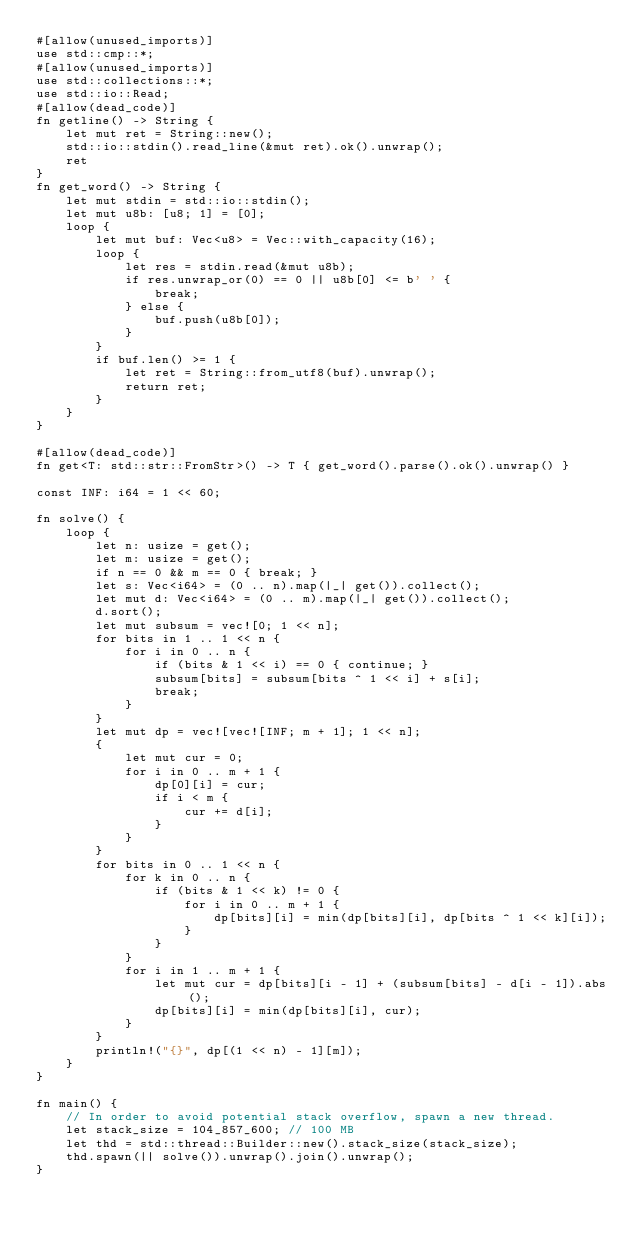Convert code to text. <code><loc_0><loc_0><loc_500><loc_500><_Rust_>#[allow(unused_imports)]
use std::cmp::*;
#[allow(unused_imports)]
use std::collections::*;
use std::io::Read;
#[allow(dead_code)]
fn getline() -> String {
    let mut ret = String::new();
    std::io::stdin().read_line(&mut ret).ok().unwrap();
    ret
}
fn get_word() -> String {
    let mut stdin = std::io::stdin();
    let mut u8b: [u8; 1] = [0];
    loop {
        let mut buf: Vec<u8> = Vec::with_capacity(16);
        loop {
            let res = stdin.read(&mut u8b);
            if res.unwrap_or(0) == 0 || u8b[0] <= b' ' {
                break;
            } else {
                buf.push(u8b[0]);
            }
        }
        if buf.len() >= 1 {
            let ret = String::from_utf8(buf).unwrap();
            return ret;
        }
    }
}

#[allow(dead_code)]
fn get<T: std::str::FromStr>() -> T { get_word().parse().ok().unwrap() }

const INF: i64 = 1 << 60;

fn solve() {
    loop {
        let n: usize = get();
        let m: usize = get();
        if n == 0 && m == 0 { break; }
        let s: Vec<i64> = (0 .. n).map(|_| get()).collect();
        let mut d: Vec<i64> = (0 .. m).map(|_| get()).collect();
        d.sort();
        let mut subsum = vec![0; 1 << n];
        for bits in 1 .. 1 << n {
            for i in 0 .. n {
                if (bits & 1 << i) == 0 { continue; }
                subsum[bits] = subsum[bits ^ 1 << i] + s[i];
                break;
            }
        }
        let mut dp = vec![vec![INF; m + 1]; 1 << n];
        {
            let mut cur = 0;
            for i in 0 .. m + 1 {
                dp[0][i] = cur;
                if i < m {
                    cur += d[i];
                }
            }
        }
        for bits in 0 .. 1 << n {
            for k in 0 .. n {
                if (bits & 1 << k) != 0 {
                    for i in 0 .. m + 1 {
                        dp[bits][i] = min(dp[bits][i], dp[bits ^ 1 << k][i]);
                    }
                }
            }
            for i in 1 .. m + 1 {
                let mut cur = dp[bits][i - 1] + (subsum[bits] - d[i - 1]).abs();
                dp[bits][i] = min(dp[bits][i], cur);
            }
        }
        println!("{}", dp[(1 << n) - 1][m]);
    }
}

fn main() {
    // In order to avoid potential stack overflow, spawn a new thread.
    let stack_size = 104_857_600; // 100 MB
    let thd = std::thread::Builder::new().stack_size(stack_size);
    thd.spawn(|| solve()).unwrap().join().unwrap();
}

</code> 